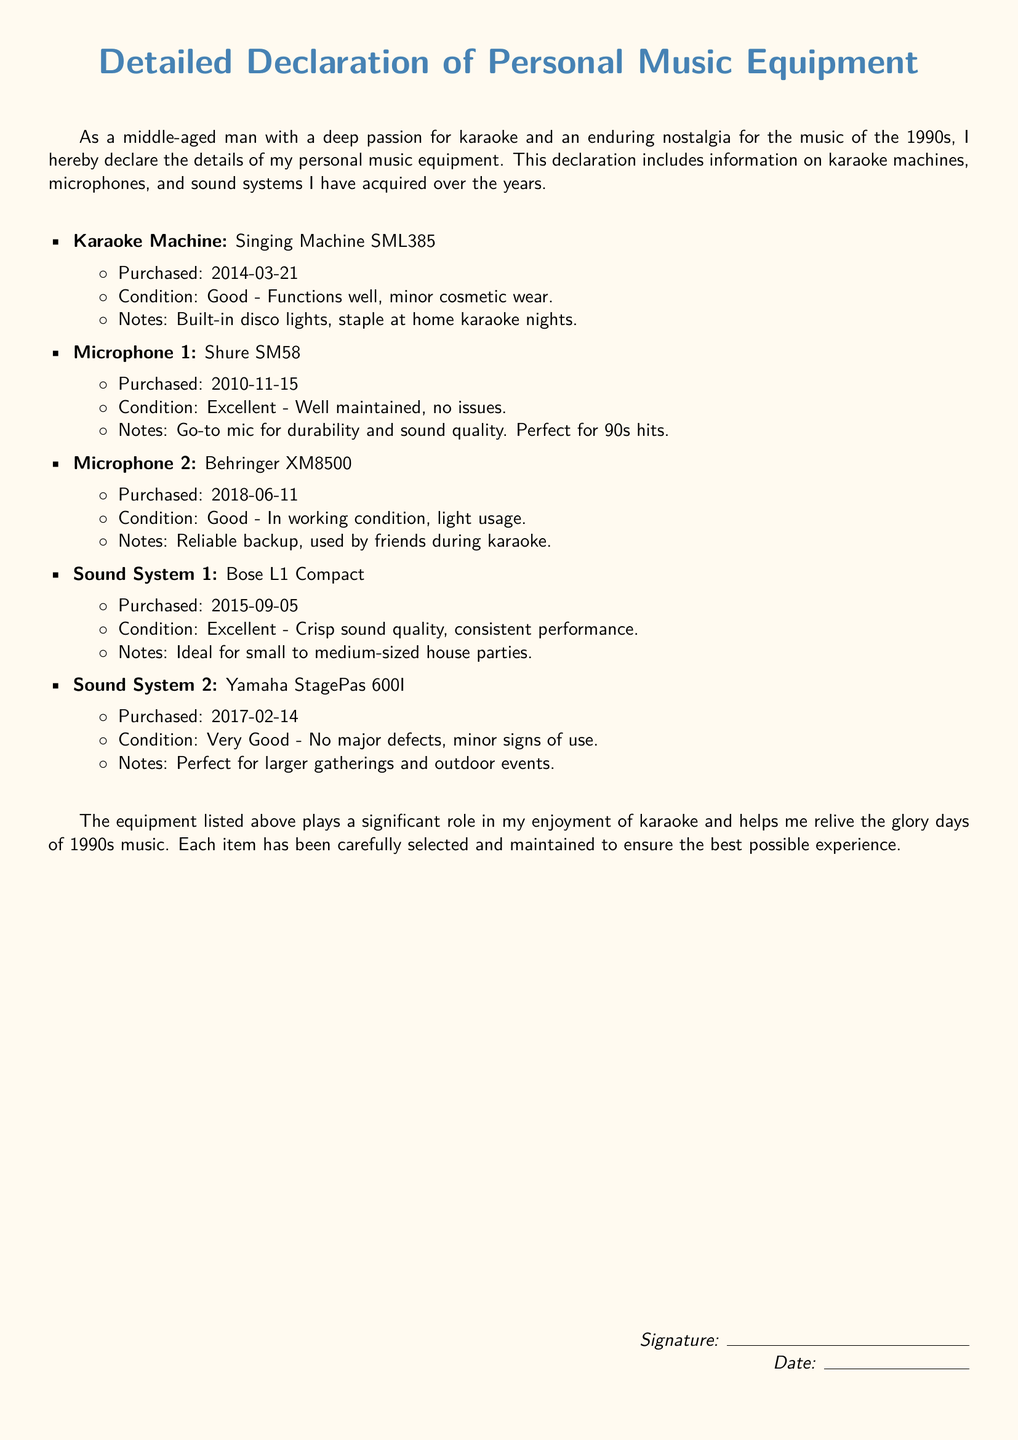What is the model of the karaoke machine? The document specifies the karaoke machine as the Singing Machine SML385.
Answer: Singing Machine SML385 When was the Shure SM58 microphone purchased? The purchase date for the Shure SM58 microphone is listed as 2010-11-15.
Answer: 2010-11-15 What condition is the Yamaha StagePas 600I sound system in? The document states that the Yamaha StagePas 600I is in very good condition with minor signs of use.
Answer: Very Good How many microphones are listed in the document? There are two microphones mentioned in the document: Shure SM58 and Behringer XM8500.
Answer: 2 What feature is highlighted about the Singing Machine SML385? The document notes that the Singing Machine SML385 has built-in disco lights, which is a key feature.
Answer: Built-in disco lights Which sound system is described as ideal for small to medium-sized house parties? The Bose L1 Compact sound system is indicated as ideal for small to medium-sized house parties.
Answer: Bose L1 Compact What was purchased closest to the year 2015? The Bose L1 Compact was purchased on 2015-09-05, which is the closest purchase to that year.
Answer: Bose L1 Compact What is the main purpose of the listed equipment according to the document? The document mentions that the equipment plays a significant role in the enjoyment of karaoke and reliving 1990s music.
Answer: Enjoyment of karaoke and reliving 1990s music 